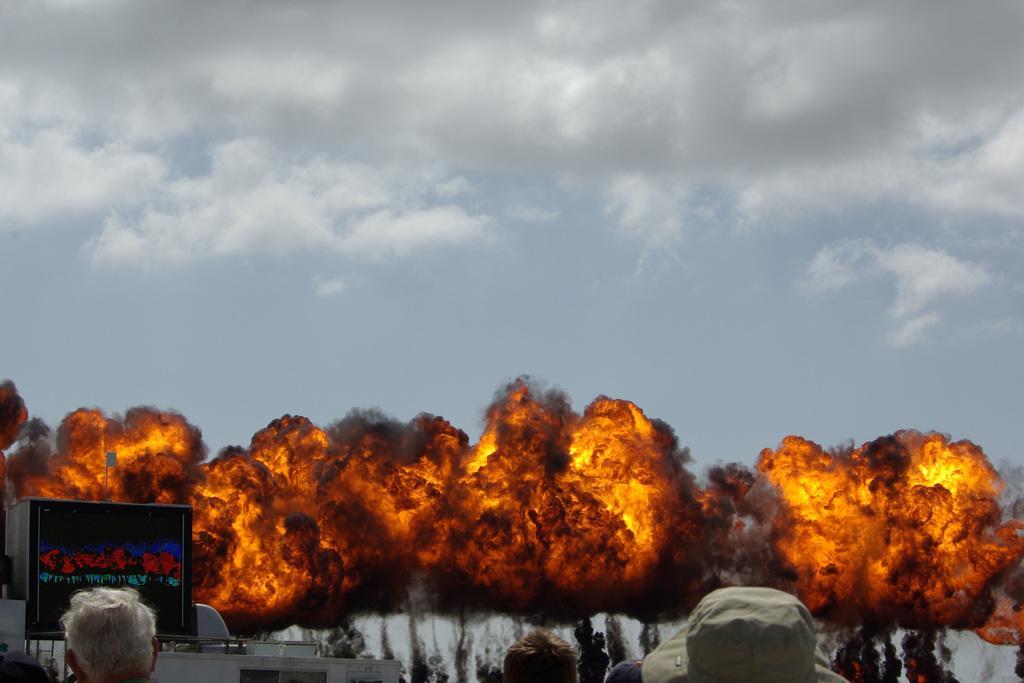How would you summarize this image in a sentence or two? There are people, poster, it seems like a vehicle and fire in the foreground area of the image and sky in the background area. 